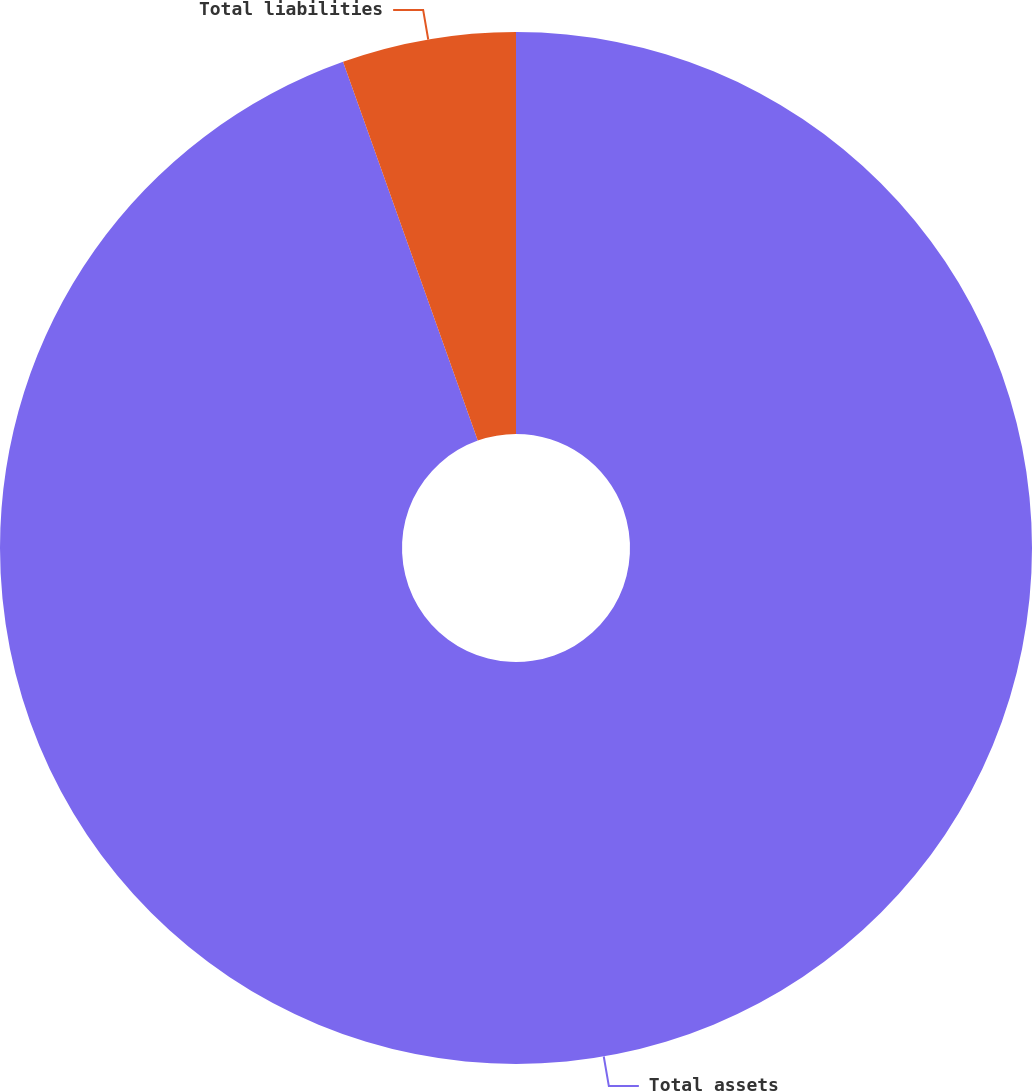Convert chart to OTSL. <chart><loc_0><loc_0><loc_500><loc_500><pie_chart><fcel>Total assets<fcel>Total liabilities<nl><fcel>94.56%<fcel>5.44%<nl></chart> 